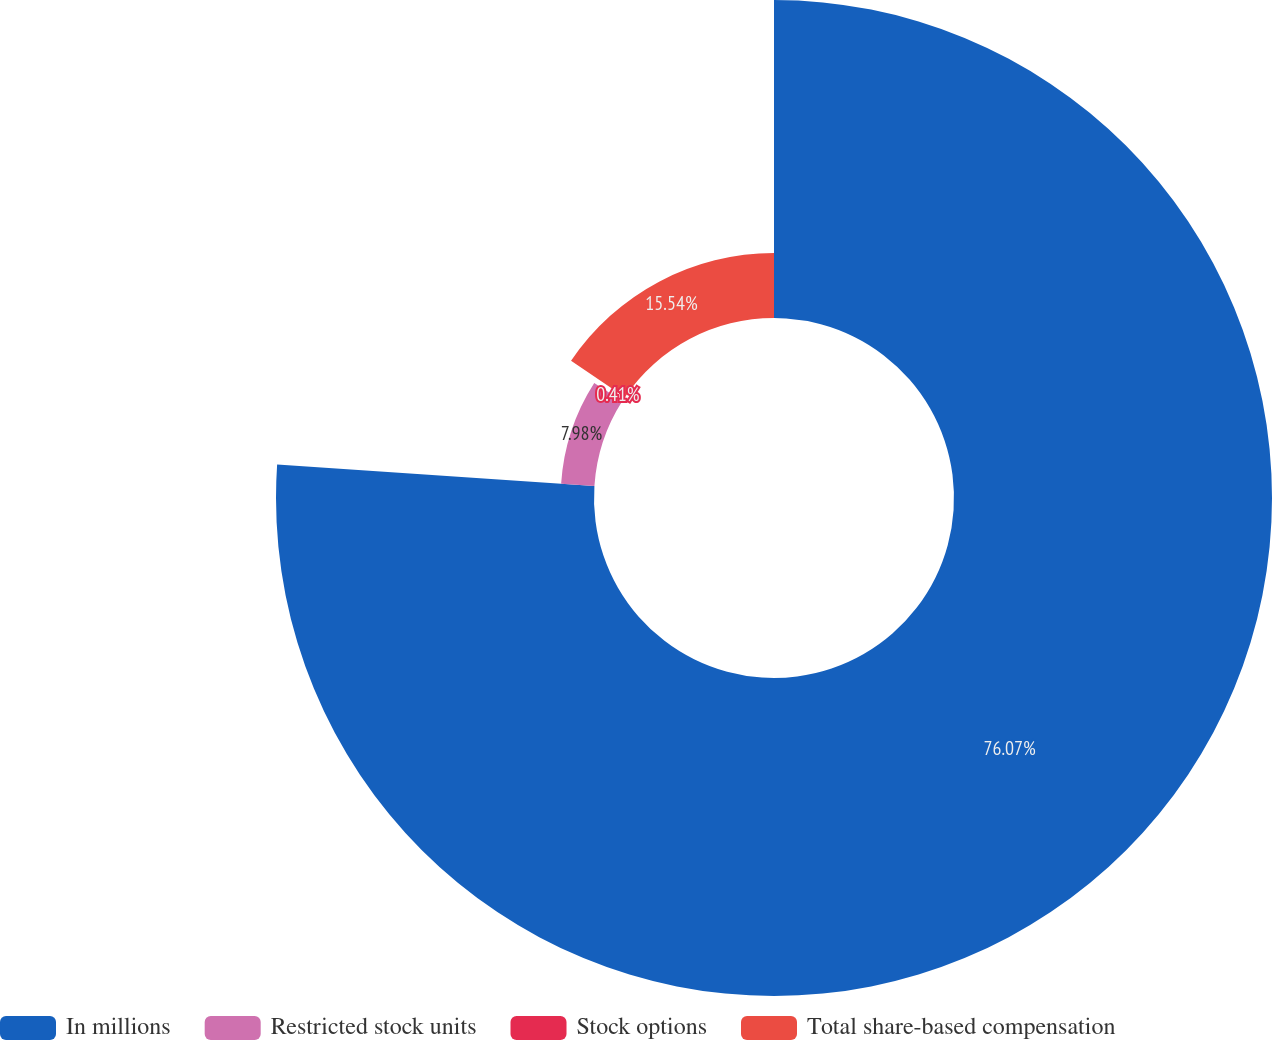<chart> <loc_0><loc_0><loc_500><loc_500><pie_chart><fcel>In millions<fcel>Restricted stock units<fcel>Stock options<fcel>Total share-based compensation<nl><fcel>76.07%<fcel>7.98%<fcel>0.41%<fcel>15.54%<nl></chart> 